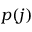<formula> <loc_0><loc_0><loc_500><loc_500>p ( j )</formula> 